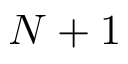Convert formula to latex. <formula><loc_0><loc_0><loc_500><loc_500>N + 1</formula> 